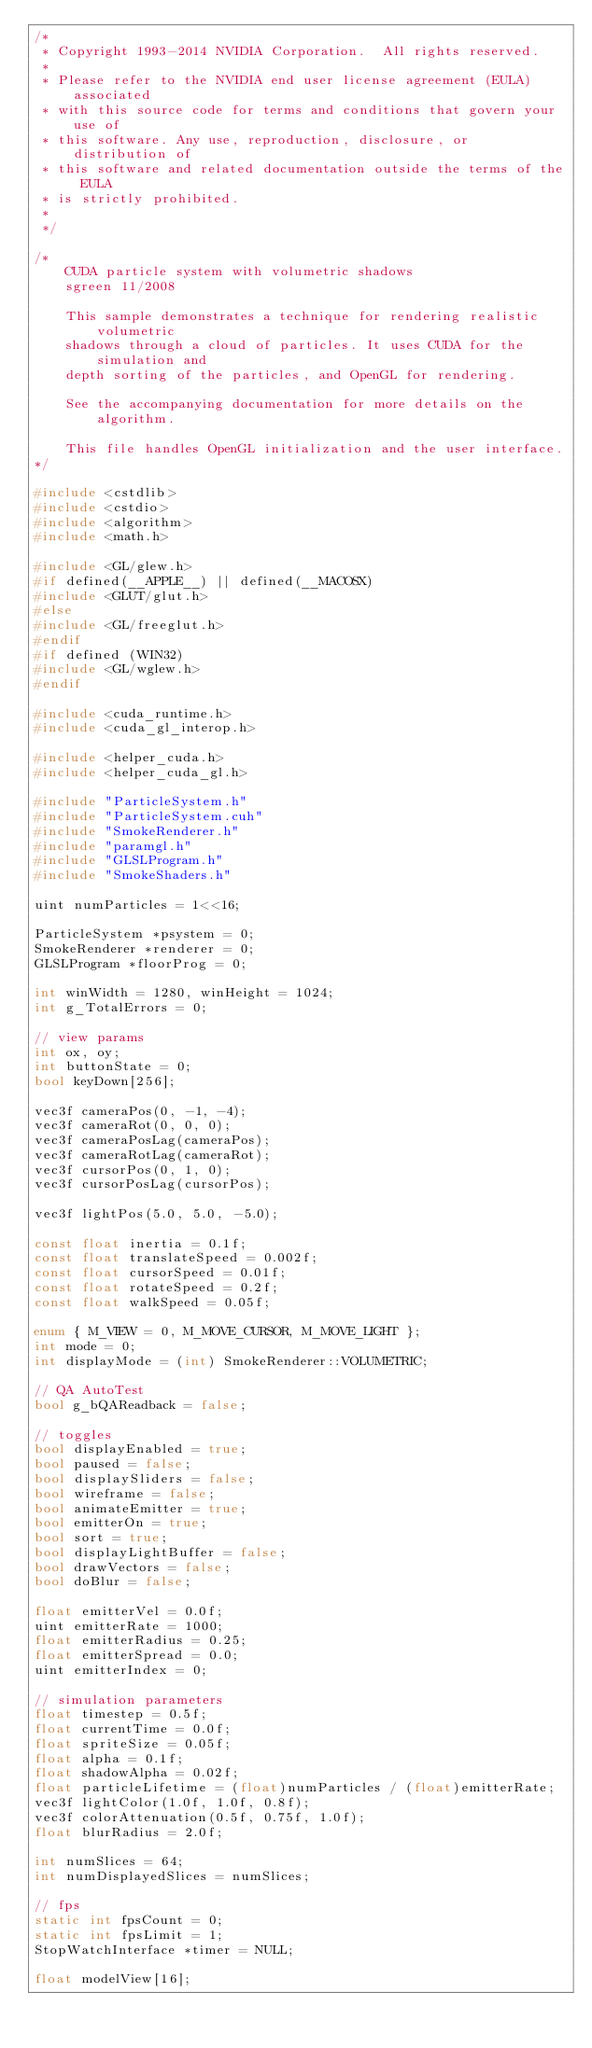<code> <loc_0><loc_0><loc_500><loc_500><_C++_>/*
 * Copyright 1993-2014 NVIDIA Corporation.  All rights reserved.
 *
 * Please refer to the NVIDIA end user license agreement (EULA) associated
 * with this source code for terms and conditions that govern your use of
 * this software. Any use, reproduction, disclosure, or distribution of
 * this software and related documentation outside the terms of the EULA
 * is strictly prohibited.
 *
 */

/*
    CUDA particle system with volumetric shadows
    sgreen 11/2008

    This sample demonstrates a technique for rendering realistic volumetric
    shadows through a cloud of particles. It uses CUDA for the simulation and
    depth sorting of the particles, and OpenGL for rendering.

    See the accompanying documentation for more details on the algorithm.

    This file handles OpenGL initialization and the user interface.
*/

#include <cstdlib>
#include <cstdio>
#include <algorithm>
#include <math.h>

#include <GL/glew.h>
#if defined(__APPLE__) || defined(__MACOSX)
#include <GLUT/glut.h>
#else
#include <GL/freeglut.h>
#endif
#if defined (WIN32)
#include <GL/wglew.h>
#endif

#include <cuda_runtime.h>
#include <cuda_gl_interop.h>

#include <helper_cuda.h>
#include <helper_cuda_gl.h>

#include "ParticleSystem.h"
#include "ParticleSystem.cuh"
#include "SmokeRenderer.h"
#include "paramgl.h"
#include "GLSLProgram.h"
#include "SmokeShaders.h"

uint numParticles = 1<<16;

ParticleSystem *psystem = 0;
SmokeRenderer *renderer = 0;
GLSLProgram *floorProg = 0;

int winWidth = 1280, winHeight = 1024;
int g_TotalErrors = 0;

// view params
int ox, oy;
int buttonState = 0;
bool keyDown[256];

vec3f cameraPos(0, -1, -4);
vec3f cameraRot(0, 0, 0);
vec3f cameraPosLag(cameraPos);
vec3f cameraRotLag(cameraRot);
vec3f cursorPos(0, 1, 0);
vec3f cursorPosLag(cursorPos);

vec3f lightPos(5.0, 5.0, -5.0);

const float inertia = 0.1f;
const float translateSpeed = 0.002f;
const float cursorSpeed = 0.01f;
const float rotateSpeed = 0.2f;
const float walkSpeed = 0.05f;

enum { M_VIEW = 0, M_MOVE_CURSOR, M_MOVE_LIGHT };
int mode = 0;
int displayMode = (int) SmokeRenderer::VOLUMETRIC;

// QA AutoTest
bool g_bQAReadback = false;

// toggles
bool displayEnabled = true;
bool paused = false;
bool displaySliders = false;
bool wireframe = false;
bool animateEmitter = true;
bool emitterOn = true;
bool sort = true;
bool displayLightBuffer = false;
bool drawVectors = false;
bool doBlur = false;

float emitterVel = 0.0f;
uint emitterRate = 1000;
float emitterRadius = 0.25;
float emitterSpread = 0.0;
uint emitterIndex = 0;

// simulation parameters
float timestep = 0.5f;
float currentTime = 0.0f;
float spriteSize = 0.05f;
float alpha = 0.1f;
float shadowAlpha = 0.02f;
float particleLifetime = (float)numParticles / (float)emitterRate;
vec3f lightColor(1.0f, 1.0f, 0.8f);
vec3f colorAttenuation(0.5f, 0.75f, 1.0f);
float blurRadius = 2.0f;

int numSlices = 64;
int numDisplayedSlices = numSlices;

// fps
static int fpsCount = 0;
static int fpsLimit = 1;
StopWatchInterface *timer = NULL;

float modelView[16];</code> 